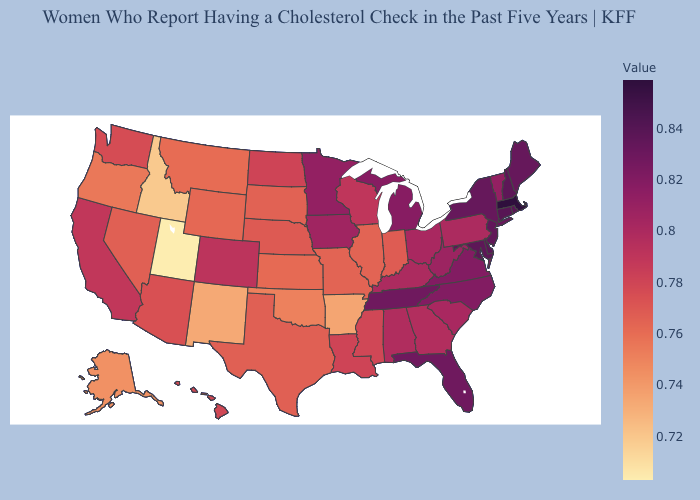Among the states that border Arizona , which have the highest value?
Keep it brief. Colorado. Does Alaska have the highest value in the USA?
Answer briefly. No. Among the states that border Washington , does Idaho have the highest value?
Give a very brief answer. No. Which states have the lowest value in the MidWest?
Write a very short answer. Kansas. Does Utah have the lowest value in the USA?
Be succinct. Yes. Among the states that border Washington , does Oregon have the highest value?
Quick response, please. Yes. Does Georgia have the highest value in the South?
Write a very short answer. No. Does Utah have the lowest value in the USA?
Answer briefly. Yes. 